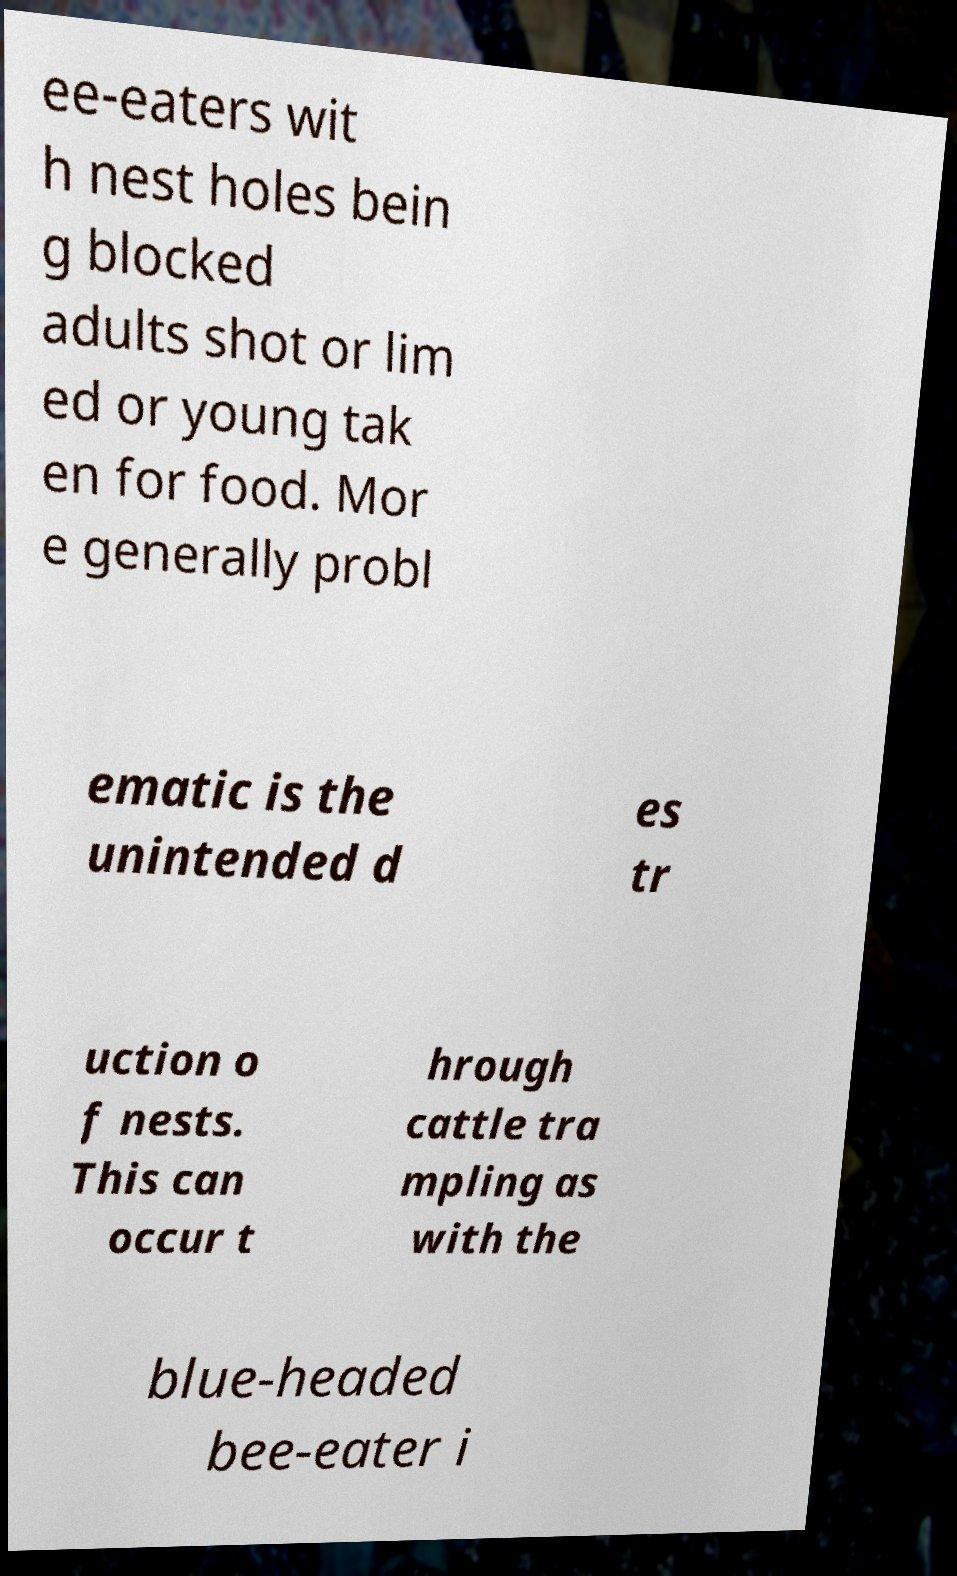I need the written content from this picture converted into text. Can you do that? ee-eaters wit h nest holes bein g blocked adults shot or lim ed or young tak en for food. Mor e generally probl ematic is the unintended d es tr uction o f nests. This can occur t hrough cattle tra mpling as with the blue-headed bee-eater i 